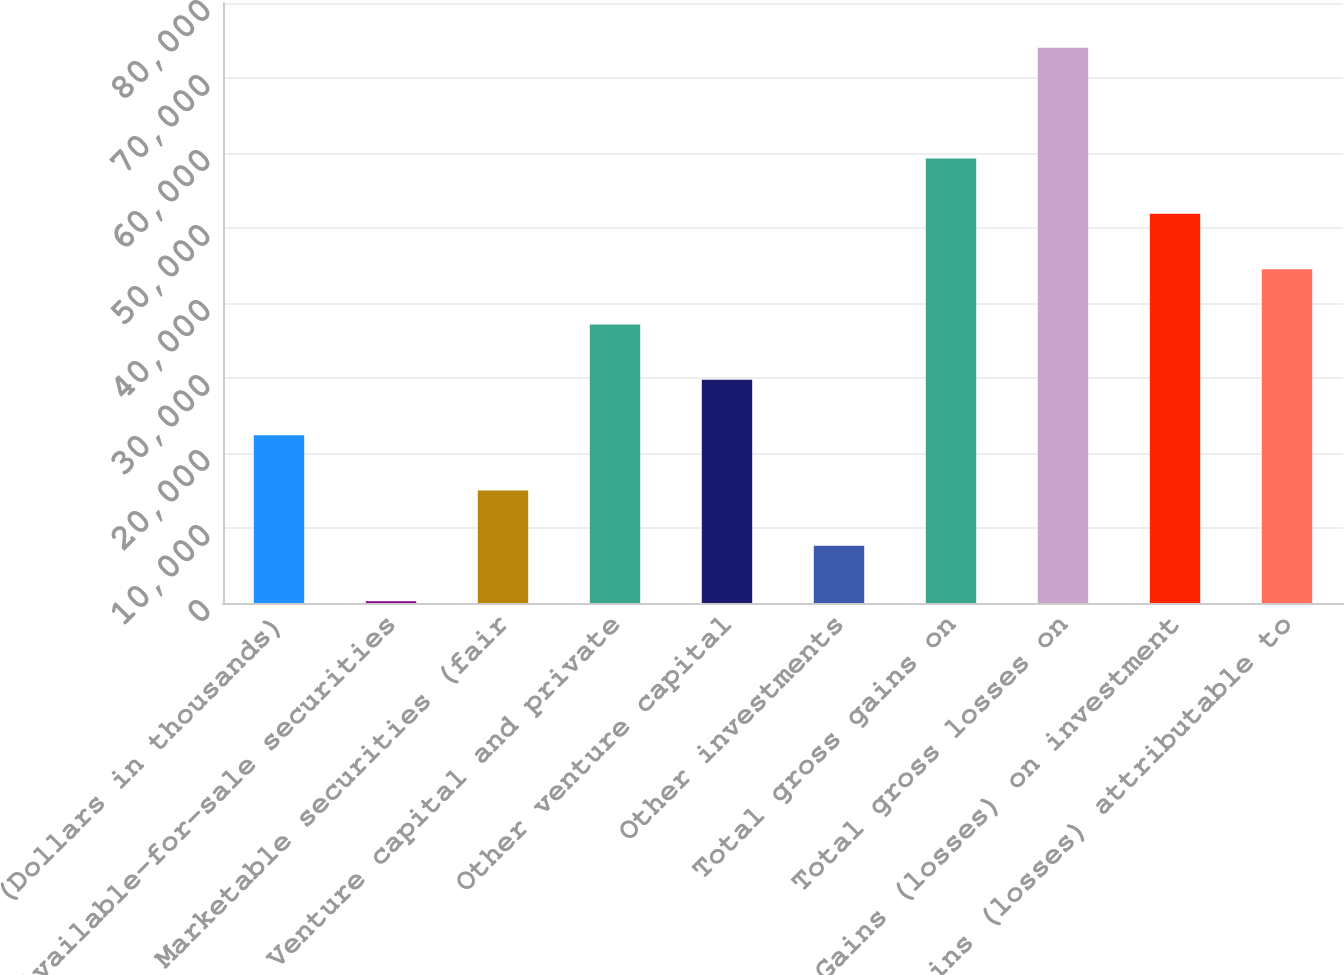Convert chart. <chart><loc_0><loc_0><loc_500><loc_500><bar_chart><fcel>(Dollars in thousands)<fcel>Available-for-sale securities<fcel>Marketable securities (fair<fcel>Venture capital and private<fcel>Other venture capital<fcel>Other investments<fcel>Total gross gains on<fcel>Total gross losses on<fcel>Gains (losses) on investment<fcel>Gains (losses) attributable to<nl><fcel>22379.7<fcel>246<fcel>15001.8<fcel>37135.5<fcel>29757.6<fcel>7623.9<fcel>59269.2<fcel>74025<fcel>51891.3<fcel>44513.4<nl></chart> 